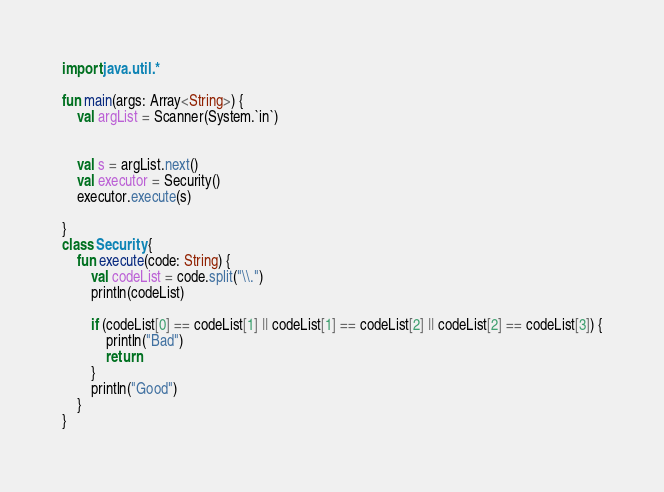Convert code to text. <code><loc_0><loc_0><loc_500><loc_500><_Kotlin_>import java.util.*

fun main(args: Array<String>) {
    val argList = Scanner(System.`in`)


    val s = argList.next()
    val executor = Security()
    executor.execute(s)

}
class Security {
    fun execute(code: String) {
        val codeList = code.split("\\.")
        println(codeList)

        if (codeList[0] == codeList[1] || codeList[1] == codeList[2] || codeList[2] == codeList[3]) {
            println("Bad")
            return
        }
        println("Good")
    }
}
</code> 